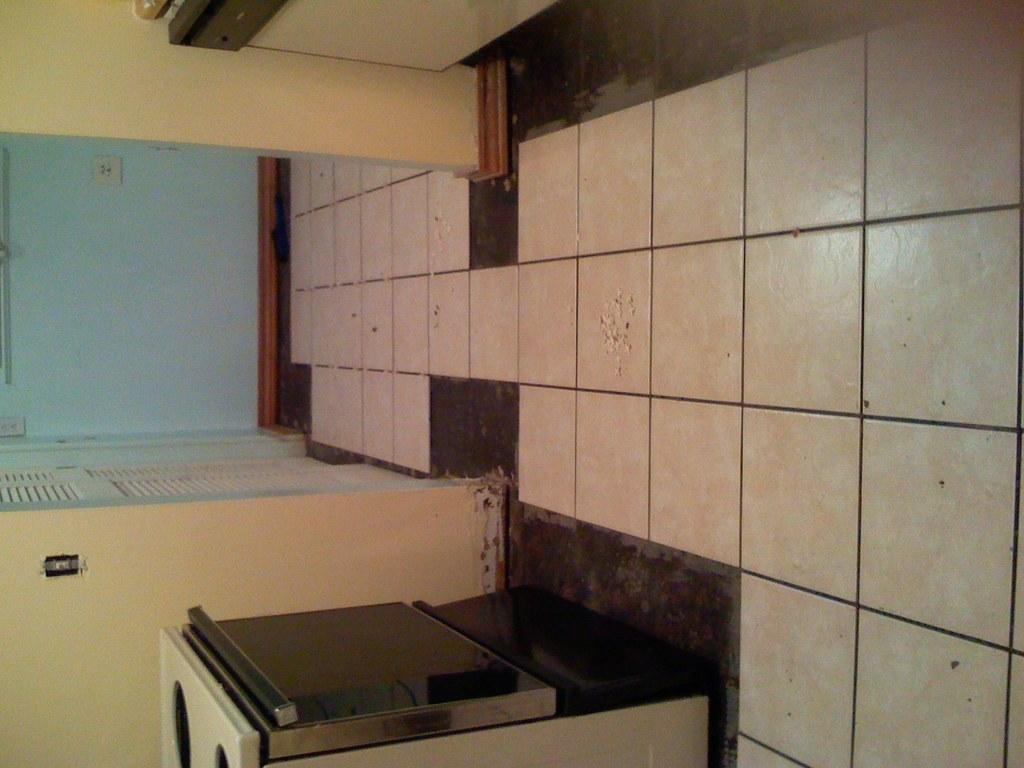What appliance is present in the image? There is a microwave oven in the image. Where is the microwave oven located in the image? The microwave oven is located at the bottom of the image. What surface is visible beneath the microwave oven? There is a floor visible in the image. What can be seen behind the microwave oven in the image? There is a wall in the background of the image. How many pizzas are being cooked in the microwave oven in the image? There is no indication of pizzas or cooking in the image; it only shows a microwave oven. Can you see the brother of the person who owns the microwave oven in the image? There is no person or any indication of a brother present in the image. 